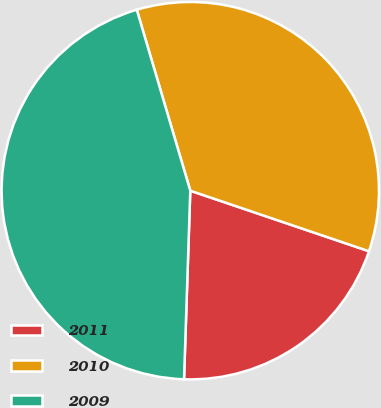Convert chart to OTSL. <chart><loc_0><loc_0><loc_500><loc_500><pie_chart><fcel>2011<fcel>2010<fcel>2009<nl><fcel>20.33%<fcel>34.78%<fcel>44.9%<nl></chart> 